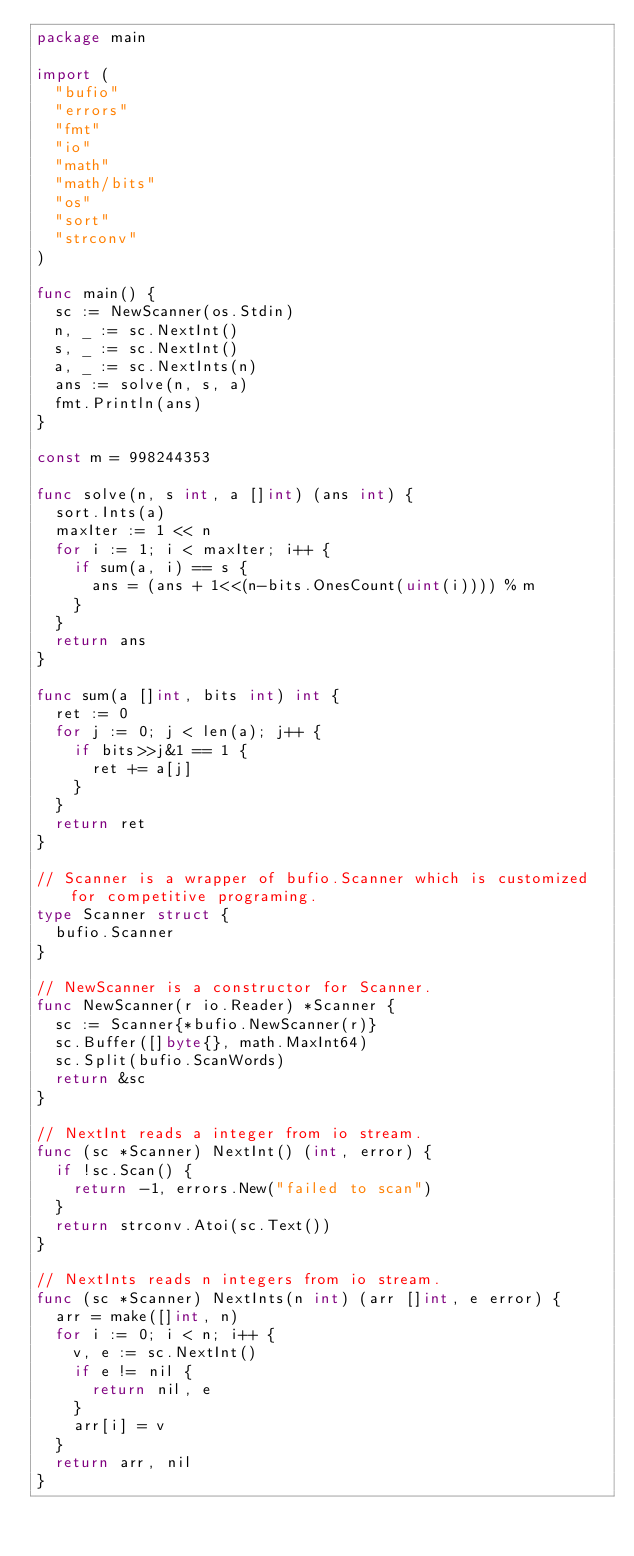<code> <loc_0><loc_0><loc_500><loc_500><_Go_>package main

import (
	"bufio"
	"errors"
	"fmt"
	"io"
	"math"
	"math/bits"
	"os"
	"sort"
	"strconv"
)

func main() {
	sc := NewScanner(os.Stdin)
	n, _ := sc.NextInt()
	s, _ := sc.NextInt()
	a, _ := sc.NextInts(n)
	ans := solve(n, s, a)
	fmt.Println(ans)
}

const m = 998244353

func solve(n, s int, a []int) (ans int) {
	sort.Ints(a)
	maxIter := 1 << n
	for i := 1; i < maxIter; i++ {
		if sum(a, i) == s {
			ans = (ans + 1<<(n-bits.OnesCount(uint(i)))) % m
		}
	}
	return ans
}

func sum(a []int, bits int) int {
	ret := 0
	for j := 0; j < len(a); j++ {
		if bits>>j&1 == 1 {
			ret += a[j]
		}
	}
	return ret
}

// Scanner is a wrapper of bufio.Scanner which is customized for competitive programing.
type Scanner struct {
	bufio.Scanner
}

// NewScanner is a constructor for Scanner.
func NewScanner(r io.Reader) *Scanner {
	sc := Scanner{*bufio.NewScanner(r)}
	sc.Buffer([]byte{}, math.MaxInt64)
	sc.Split(bufio.ScanWords)
	return &sc
}

// NextInt reads a integer from io stream.
func (sc *Scanner) NextInt() (int, error) {
	if !sc.Scan() {
		return -1, errors.New("failed to scan")
	}
	return strconv.Atoi(sc.Text())
}

// NextInts reads n integers from io stream.
func (sc *Scanner) NextInts(n int) (arr []int, e error) {
	arr = make([]int, n)
	for i := 0; i < n; i++ {
		v, e := sc.NextInt()
		if e != nil {
			return nil, e
		}
		arr[i] = v
	}
	return arr, nil
}
</code> 